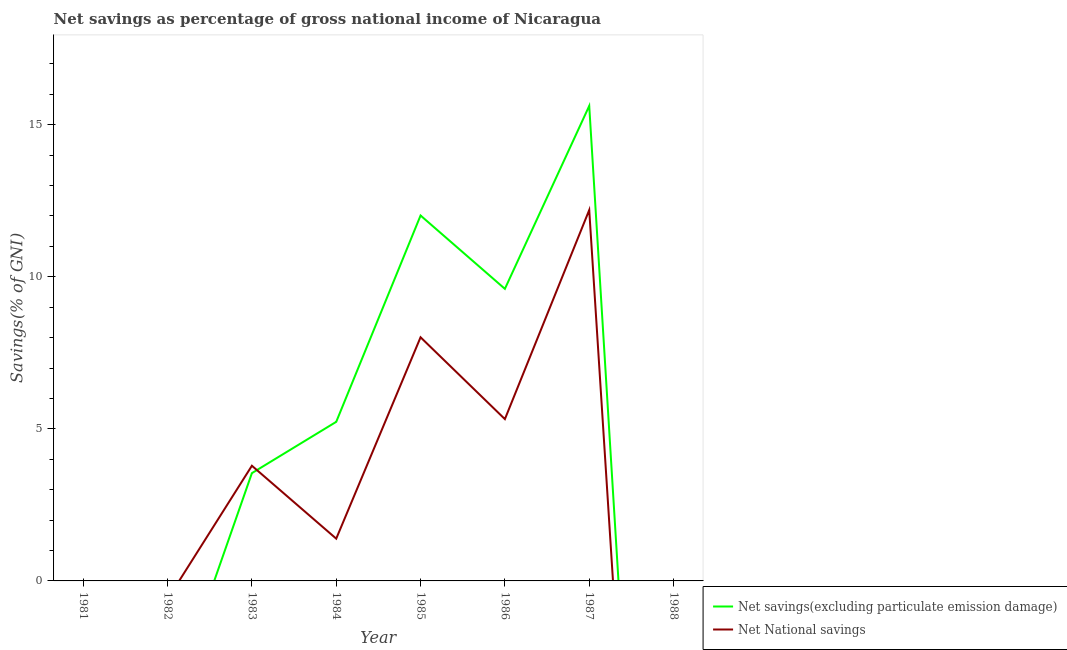How many different coloured lines are there?
Offer a very short reply. 2. Does the line corresponding to net national savings intersect with the line corresponding to net savings(excluding particulate emission damage)?
Your answer should be compact. Yes. Is the number of lines equal to the number of legend labels?
Give a very brief answer. No. What is the net savings(excluding particulate emission damage) in 1988?
Give a very brief answer. 0. Across all years, what is the maximum net national savings?
Offer a very short reply. 12.19. Across all years, what is the minimum net savings(excluding particulate emission damage)?
Give a very brief answer. 0. What is the total net savings(excluding particulate emission damage) in the graph?
Your answer should be very brief. 46.01. What is the difference between the net savings(excluding particulate emission damage) in 1985 and that in 1986?
Your response must be concise. 2.41. What is the difference between the net savings(excluding particulate emission damage) in 1985 and the net national savings in 1984?
Keep it short and to the point. 10.63. What is the average net savings(excluding particulate emission damage) per year?
Ensure brevity in your answer.  5.75. In the year 1986, what is the difference between the net savings(excluding particulate emission damage) and net national savings?
Provide a short and direct response. 4.28. What is the ratio of the net savings(excluding particulate emission damage) in 1986 to that in 1987?
Offer a very short reply. 0.61. Is the difference between the net national savings in 1985 and 1986 greater than the difference between the net savings(excluding particulate emission damage) in 1985 and 1986?
Provide a short and direct response. Yes. What is the difference between the highest and the second highest net national savings?
Keep it short and to the point. 4.18. What is the difference between the highest and the lowest net savings(excluding particulate emission damage)?
Offer a terse response. 15.62. Does the net savings(excluding particulate emission damage) monotonically increase over the years?
Offer a very short reply. No. How many years are there in the graph?
Give a very brief answer. 8. Are the values on the major ticks of Y-axis written in scientific E-notation?
Offer a terse response. No. Where does the legend appear in the graph?
Offer a terse response. Bottom right. How are the legend labels stacked?
Provide a succinct answer. Vertical. What is the title of the graph?
Make the answer very short. Net savings as percentage of gross national income of Nicaragua. What is the label or title of the Y-axis?
Offer a very short reply. Savings(% of GNI). What is the Savings(% of GNI) in Net savings(excluding particulate emission damage) in 1982?
Provide a succinct answer. 0. What is the Savings(% of GNI) of Net savings(excluding particulate emission damage) in 1983?
Your answer should be compact. 3.54. What is the Savings(% of GNI) of Net National savings in 1983?
Your answer should be very brief. 3.79. What is the Savings(% of GNI) in Net savings(excluding particulate emission damage) in 1984?
Your answer should be compact. 5.23. What is the Savings(% of GNI) in Net National savings in 1984?
Ensure brevity in your answer.  1.39. What is the Savings(% of GNI) in Net savings(excluding particulate emission damage) in 1985?
Provide a short and direct response. 12.02. What is the Savings(% of GNI) of Net National savings in 1985?
Your answer should be very brief. 8.01. What is the Savings(% of GNI) in Net savings(excluding particulate emission damage) in 1986?
Ensure brevity in your answer.  9.6. What is the Savings(% of GNI) in Net National savings in 1986?
Your response must be concise. 5.32. What is the Savings(% of GNI) of Net savings(excluding particulate emission damage) in 1987?
Make the answer very short. 15.62. What is the Savings(% of GNI) in Net National savings in 1987?
Your answer should be compact. 12.19. What is the Savings(% of GNI) of Net National savings in 1988?
Offer a terse response. 0. Across all years, what is the maximum Savings(% of GNI) of Net savings(excluding particulate emission damage)?
Make the answer very short. 15.62. Across all years, what is the maximum Savings(% of GNI) in Net National savings?
Offer a terse response. 12.19. Across all years, what is the minimum Savings(% of GNI) in Net National savings?
Ensure brevity in your answer.  0. What is the total Savings(% of GNI) in Net savings(excluding particulate emission damage) in the graph?
Make the answer very short. 46.01. What is the total Savings(% of GNI) of Net National savings in the graph?
Offer a very short reply. 30.7. What is the difference between the Savings(% of GNI) in Net savings(excluding particulate emission damage) in 1983 and that in 1984?
Provide a short and direct response. -1.69. What is the difference between the Savings(% of GNI) in Net National savings in 1983 and that in 1984?
Your answer should be very brief. 2.4. What is the difference between the Savings(% of GNI) in Net savings(excluding particulate emission damage) in 1983 and that in 1985?
Offer a terse response. -8.47. What is the difference between the Savings(% of GNI) in Net National savings in 1983 and that in 1985?
Offer a very short reply. -4.22. What is the difference between the Savings(% of GNI) in Net savings(excluding particulate emission damage) in 1983 and that in 1986?
Offer a very short reply. -6.06. What is the difference between the Savings(% of GNI) of Net National savings in 1983 and that in 1986?
Offer a very short reply. -1.53. What is the difference between the Savings(% of GNI) of Net savings(excluding particulate emission damage) in 1983 and that in 1987?
Make the answer very short. -12.07. What is the difference between the Savings(% of GNI) in Net National savings in 1983 and that in 1987?
Your response must be concise. -8.41. What is the difference between the Savings(% of GNI) of Net savings(excluding particulate emission damage) in 1984 and that in 1985?
Keep it short and to the point. -6.78. What is the difference between the Savings(% of GNI) in Net National savings in 1984 and that in 1985?
Your answer should be compact. -6.62. What is the difference between the Savings(% of GNI) of Net savings(excluding particulate emission damage) in 1984 and that in 1986?
Provide a short and direct response. -4.37. What is the difference between the Savings(% of GNI) in Net National savings in 1984 and that in 1986?
Make the answer very short. -3.93. What is the difference between the Savings(% of GNI) in Net savings(excluding particulate emission damage) in 1984 and that in 1987?
Keep it short and to the point. -10.39. What is the difference between the Savings(% of GNI) of Net National savings in 1984 and that in 1987?
Give a very brief answer. -10.8. What is the difference between the Savings(% of GNI) in Net savings(excluding particulate emission damage) in 1985 and that in 1986?
Provide a succinct answer. 2.41. What is the difference between the Savings(% of GNI) in Net National savings in 1985 and that in 1986?
Keep it short and to the point. 2.69. What is the difference between the Savings(% of GNI) of Net savings(excluding particulate emission damage) in 1985 and that in 1987?
Offer a very short reply. -3.6. What is the difference between the Savings(% of GNI) of Net National savings in 1985 and that in 1987?
Give a very brief answer. -4.18. What is the difference between the Savings(% of GNI) of Net savings(excluding particulate emission damage) in 1986 and that in 1987?
Ensure brevity in your answer.  -6.01. What is the difference between the Savings(% of GNI) of Net National savings in 1986 and that in 1987?
Keep it short and to the point. -6.87. What is the difference between the Savings(% of GNI) of Net savings(excluding particulate emission damage) in 1983 and the Savings(% of GNI) of Net National savings in 1984?
Give a very brief answer. 2.15. What is the difference between the Savings(% of GNI) of Net savings(excluding particulate emission damage) in 1983 and the Savings(% of GNI) of Net National savings in 1985?
Give a very brief answer. -4.47. What is the difference between the Savings(% of GNI) in Net savings(excluding particulate emission damage) in 1983 and the Savings(% of GNI) in Net National savings in 1986?
Your answer should be compact. -1.78. What is the difference between the Savings(% of GNI) of Net savings(excluding particulate emission damage) in 1983 and the Savings(% of GNI) of Net National savings in 1987?
Ensure brevity in your answer.  -8.65. What is the difference between the Savings(% of GNI) in Net savings(excluding particulate emission damage) in 1984 and the Savings(% of GNI) in Net National savings in 1985?
Ensure brevity in your answer.  -2.78. What is the difference between the Savings(% of GNI) of Net savings(excluding particulate emission damage) in 1984 and the Savings(% of GNI) of Net National savings in 1986?
Give a very brief answer. -0.09. What is the difference between the Savings(% of GNI) in Net savings(excluding particulate emission damage) in 1984 and the Savings(% of GNI) in Net National savings in 1987?
Offer a very short reply. -6.96. What is the difference between the Savings(% of GNI) of Net savings(excluding particulate emission damage) in 1985 and the Savings(% of GNI) of Net National savings in 1986?
Make the answer very short. 6.69. What is the difference between the Savings(% of GNI) in Net savings(excluding particulate emission damage) in 1985 and the Savings(% of GNI) in Net National savings in 1987?
Ensure brevity in your answer.  -0.18. What is the difference between the Savings(% of GNI) in Net savings(excluding particulate emission damage) in 1986 and the Savings(% of GNI) in Net National savings in 1987?
Your response must be concise. -2.59. What is the average Savings(% of GNI) of Net savings(excluding particulate emission damage) per year?
Your answer should be very brief. 5.75. What is the average Savings(% of GNI) in Net National savings per year?
Your answer should be compact. 3.84. In the year 1983, what is the difference between the Savings(% of GNI) of Net savings(excluding particulate emission damage) and Savings(% of GNI) of Net National savings?
Offer a very short reply. -0.24. In the year 1984, what is the difference between the Savings(% of GNI) of Net savings(excluding particulate emission damage) and Savings(% of GNI) of Net National savings?
Make the answer very short. 3.84. In the year 1985, what is the difference between the Savings(% of GNI) in Net savings(excluding particulate emission damage) and Savings(% of GNI) in Net National savings?
Make the answer very short. 4. In the year 1986, what is the difference between the Savings(% of GNI) in Net savings(excluding particulate emission damage) and Savings(% of GNI) in Net National savings?
Your answer should be very brief. 4.28. In the year 1987, what is the difference between the Savings(% of GNI) of Net savings(excluding particulate emission damage) and Savings(% of GNI) of Net National savings?
Your answer should be very brief. 3.42. What is the ratio of the Savings(% of GNI) in Net savings(excluding particulate emission damage) in 1983 to that in 1984?
Keep it short and to the point. 0.68. What is the ratio of the Savings(% of GNI) in Net National savings in 1983 to that in 1984?
Your response must be concise. 2.72. What is the ratio of the Savings(% of GNI) in Net savings(excluding particulate emission damage) in 1983 to that in 1985?
Provide a succinct answer. 0.29. What is the ratio of the Savings(% of GNI) in Net National savings in 1983 to that in 1985?
Give a very brief answer. 0.47. What is the ratio of the Savings(% of GNI) of Net savings(excluding particulate emission damage) in 1983 to that in 1986?
Give a very brief answer. 0.37. What is the ratio of the Savings(% of GNI) of Net National savings in 1983 to that in 1986?
Provide a short and direct response. 0.71. What is the ratio of the Savings(% of GNI) of Net savings(excluding particulate emission damage) in 1983 to that in 1987?
Your answer should be compact. 0.23. What is the ratio of the Savings(% of GNI) in Net National savings in 1983 to that in 1987?
Offer a very short reply. 0.31. What is the ratio of the Savings(% of GNI) in Net savings(excluding particulate emission damage) in 1984 to that in 1985?
Give a very brief answer. 0.44. What is the ratio of the Savings(% of GNI) of Net National savings in 1984 to that in 1985?
Provide a succinct answer. 0.17. What is the ratio of the Savings(% of GNI) of Net savings(excluding particulate emission damage) in 1984 to that in 1986?
Keep it short and to the point. 0.54. What is the ratio of the Savings(% of GNI) of Net National savings in 1984 to that in 1986?
Your answer should be very brief. 0.26. What is the ratio of the Savings(% of GNI) in Net savings(excluding particulate emission damage) in 1984 to that in 1987?
Your answer should be compact. 0.33. What is the ratio of the Savings(% of GNI) of Net National savings in 1984 to that in 1987?
Keep it short and to the point. 0.11. What is the ratio of the Savings(% of GNI) of Net savings(excluding particulate emission damage) in 1985 to that in 1986?
Your answer should be compact. 1.25. What is the ratio of the Savings(% of GNI) of Net National savings in 1985 to that in 1986?
Ensure brevity in your answer.  1.51. What is the ratio of the Savings(% of GNI) of Net savings(excluding particulate emission damage) in 1985 to that in 1987?
Provide a succinct answer. 0.77. What is the ratio of the Savings(% of GNI) of Net National savings in 1985 to that in 1987?
Provide a succinct answer. 0.66. What is the ratio of the Savings(% of GNI) of Net savings(excluding particulate emission damage) in 1986 to that in 1987?
Your response must be concise. 0.61. What is the ratio of the Savings(% of GNI) of Net National savings in 1986 to that in 1987?
Your answer should be very brief. 0.44. What is the difference between the highest and the second highest Savings(% of GNI) of Net savings(excluding particulate emission damage)?
Offer a terse response. 3.6. What is the difference between the highest and the second highest Savings(% of GNI) of Net National savings?
Provide a succinct answer. 4.18. What is the difference between the highest and the lowest Savings(% of GNI) of Net savings(excluding particulate emission damage)?
Offer a very short reply. 15.62. What is the difference between the highest and the lowest Savings(% of GNI) of Net National savings?
Keep it short and to the point. 12.19. 